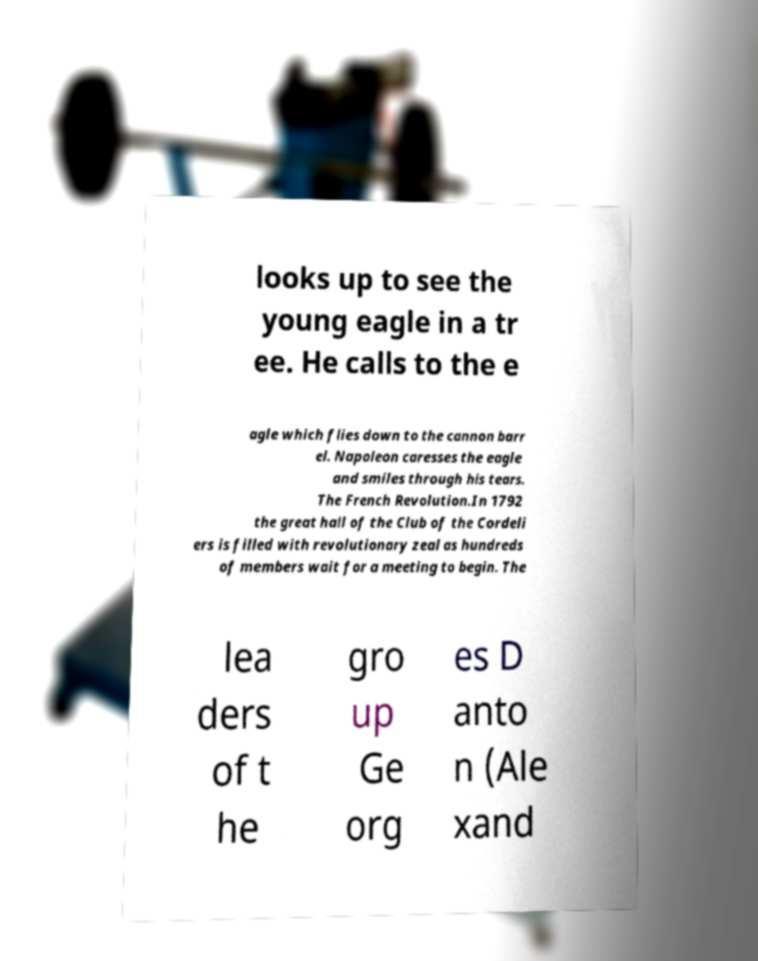What messages or text are displayed in this image? I need them in a readable, typed format. looks up to see the young eagle in a tr ee. He calls to the e agle which flies down to the cannon barr el. Napoleon caresses the eagle and smiles through his tears. The French Revolution.In 1792 the great hall of the Club of the Cordeli ers is filled with revolutionary zeal as hundreds of members wait for a meeting to begin. The lea ders of t he gro up Ge org es D anto n (Ale xand 